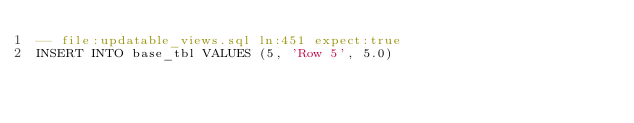Convert code to text. <code><loc_0><loc_0><loc_500><loc_500><_SQL_>-- file:updatable_views.sql ln:451 expect:true
INSERT INTO base_tbl VALUES (5, 'Row 5', 5.0)
</code> 